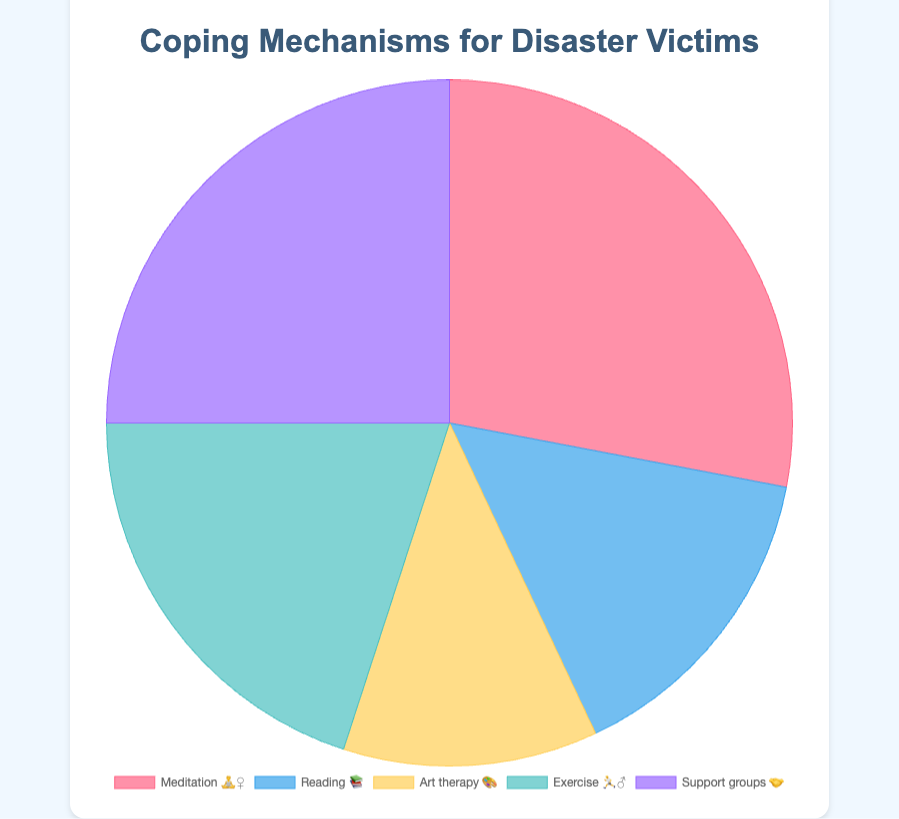What is the title of the chart? The title of the chart is displayed at the top of the figure and gives an overview of what the chart is about.
Answer: Coping Mechanisms for Disaster Victims How many coping mechanisms are shown in the chart? By counting the different segments or labels in the pie chart, we can determine the number of coping mechanisms shown.
Answer: 5 Which coping mechanism has the highest percentage? By looking at the pie chart and identifying the largest segment, we can see which coping mechanism has the highest percentage.
Answer: Meditation and mindfulness What is the percentage for Art Therapy? We can locate the segment labeled with the art therapy emoji 🎨 in the pie chart and read its corresponding percentage.
Answer: 12% How much greater is the percentage of Support Groups compared to Reading Self-Help Books? We need to subtract the percentage of Reading Self-Help Books from that of Support Groups to find the difference. 25% - 15% = 10%.
Answer: 10% Which two coping mechanisms together make up at least 50% of the total? By adding the percentages of various combinations of two mechanisms until reaching or exceeding 50%, we find the right pair. Meditation and mindfulness (28%) + Support groups (25%) = 53%.
Answer: Meditation and mindfulness and Support groups What is the average percentage of all coping mechanisms shown? Add all the percentages and divide by the number of coping mechanisms. (28% + 15% + 12% + 20% + 25%) / 5 = 20%.
Answer: 20% Describe the color scheme used in the chart. The pie chart uses different shades for each segment, including pink, blue, yellow, teal, and purple. Each color is distinct enough to easily differentiate between the coping mechanisms.
Answer: Distinct shades of pink, blue, yellow, teal, and purple Is physical exercise more or less popular than support groups? By comparing the size of the segments or the percentages, we can determine which one is more popular. Physical exercise (20%) is less than Support groups (25%).
Answer: Less Which coping mechanism is the least popular? By identifying the smallest segment in the pie chart, we find the least popular coping mechanism.
Answer: Art therapy 